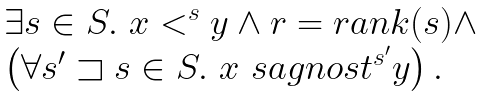Convert formula to latex. <formula><loc_0><loc_0><loc_500><loc_500>\begin{array} { l } \exists s \in S . \ x < ^ { s } y \wedge r = r a n k ( s ) \wedge \\ \left ( \forall s ^ { \prime } \sqsupset s \in S . \ x \ s a g n o s t ^ { s ^ { \prime } } y \right ) . \end{array}</formula> 